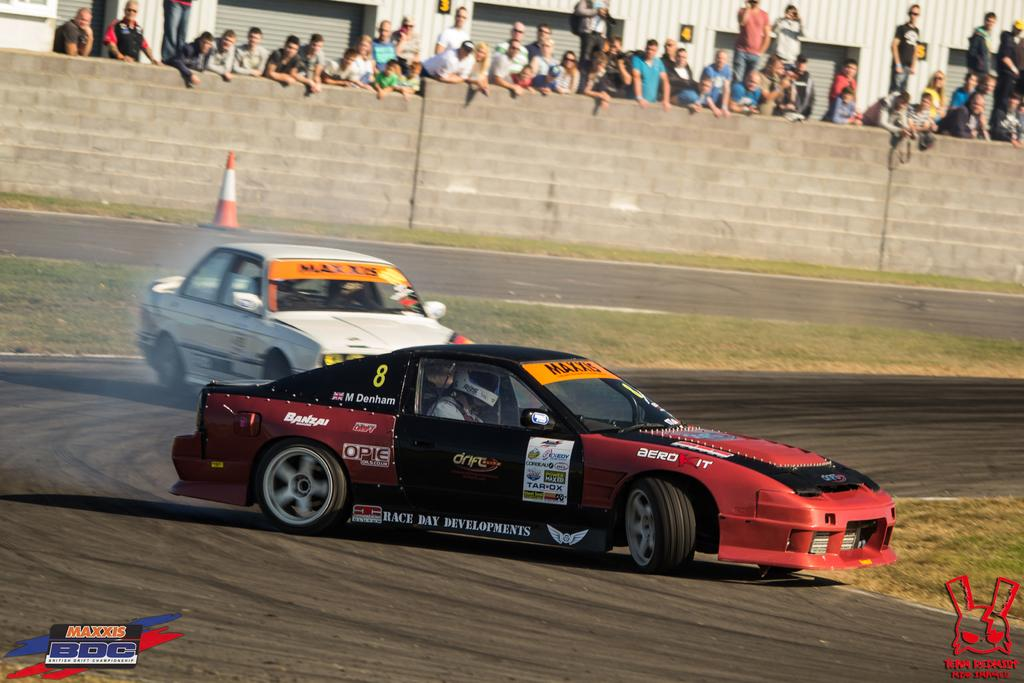What can be seen in the center of the image? There are two cars in the center of the image. What is happening in the background of the image? There are people standing in the background, and there is a wall. What safety feature is present in the image? There is a safety cone in the image. What type of terrain is visible in the image? There is grass in the image. What type of mint is growing on the safety cone in the image? There is no mint growing on the safety cone in the image; it is a safety cone without any plants. 